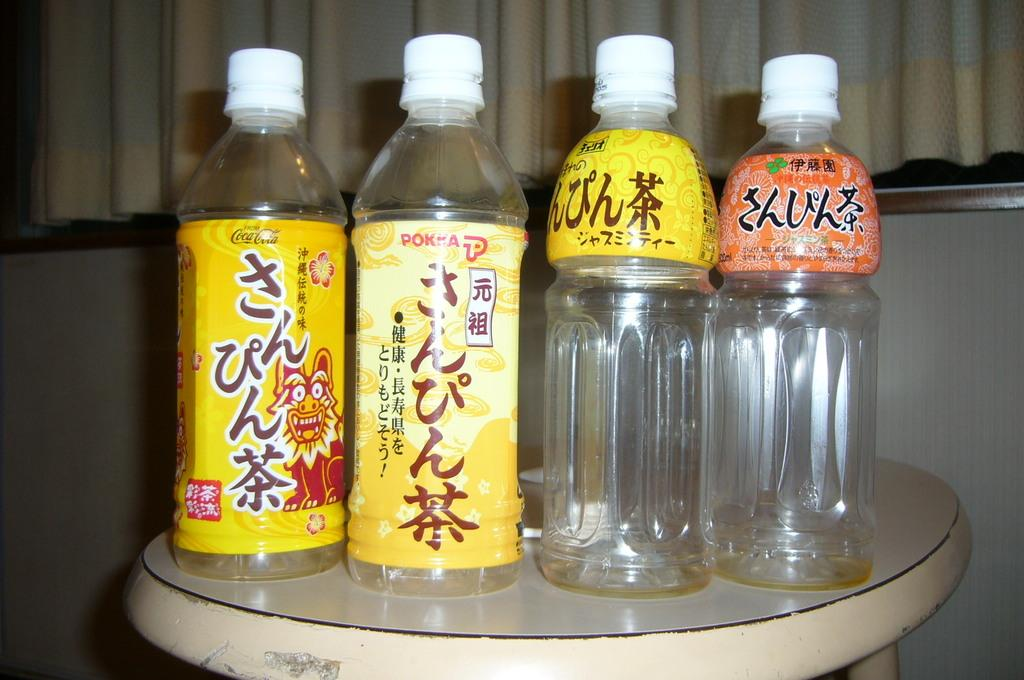What is located in the foreground of the picture? There is a table in the foreground of the picture. What can be seen on the table? There are empty water bottles on the table. What is visible in the background of the picture? There is a curtain in the background of the picture. What is below the curtain? There is a wall below the curtain. What type of food is being served on the throne in the image? There is no throne present in the image, and therefore no food can be served on it. 